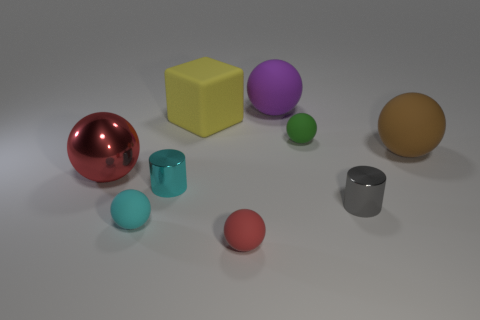What material is the brown object?
Your answer should be compact. Rubber. Do the big block and the small sphere behind the cyan metal thing have the same material?
Make the answer very short. Yes. What color is the small thing that is on the right side of the small thing behind the brown matte object?
Provide a short and direct response. Gray. There is a metallic object that is both on the left side of the tiny gray metallic object and on the right side of the large red metallic ball; what is its size?
Ensure brevity in your answer.  Small. How many other objects are there of the same shape as the large purple thing?
Your answer should be compact. 5. Does the yellow object have the same shape as the red thing behind the small cyan cylinder?
Provide a succinct answer. No. There is a small green sphere; what number of yellow blocks are to the left of it?
Your response must be concise. 1. Are there any other things that have the same material as the big yellow block?
Provide a succinct answer. Yes. There is a tiny shiny thing left of the small green thing; is its shape the same as the large yellow matte thing?
Offer a terse response. No. What color is the tiny metal cylinder in front of the tiny cyan cylinder?
Your answer should be very brief. Gray. 